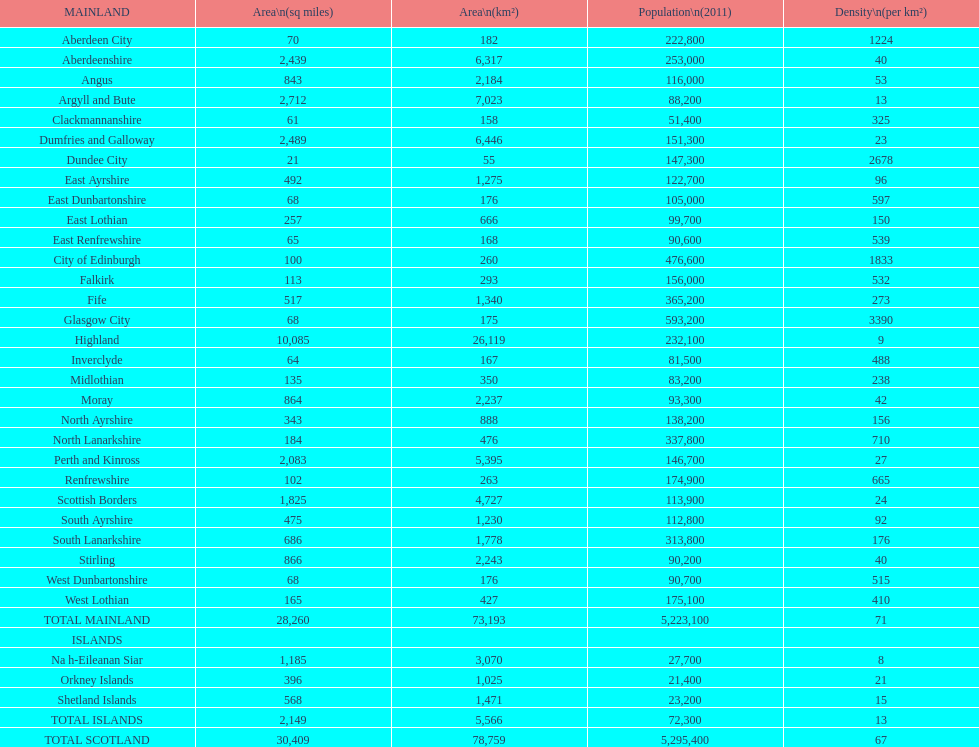Which is the only subdivision to have a greater area than argyll and bute? Highland. 